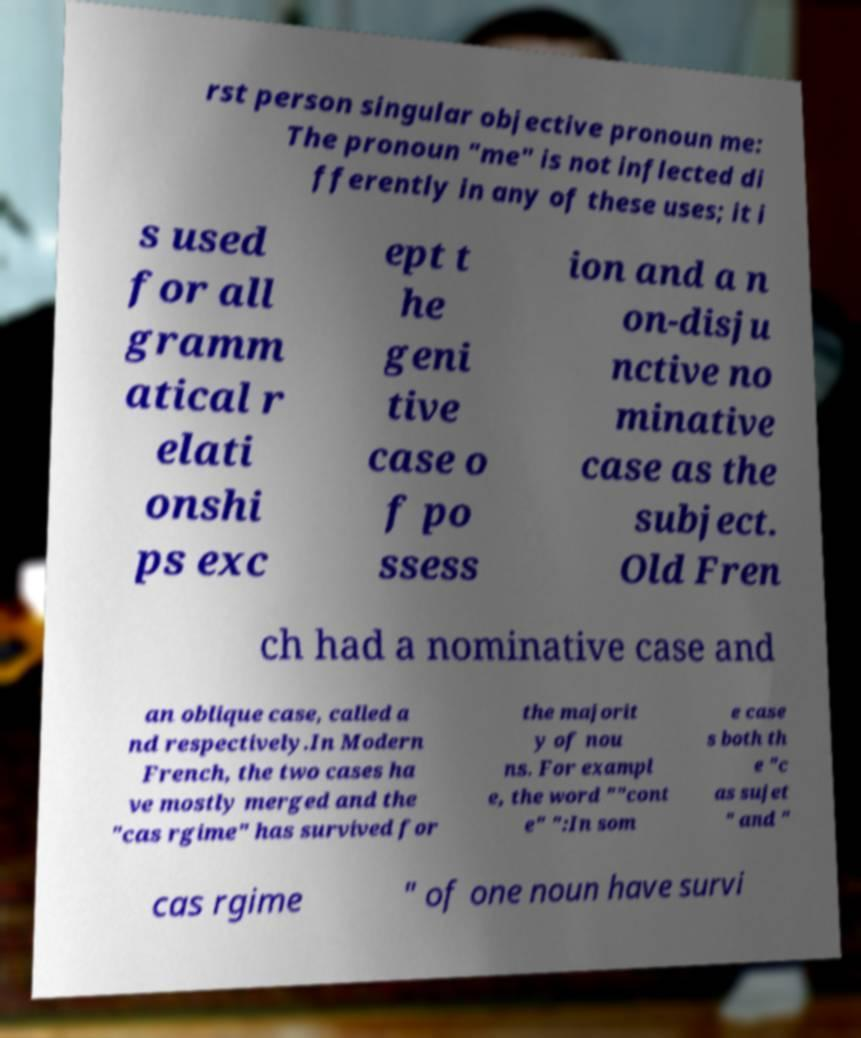What messages or text are displayed in this image? I need them in a readable, typed format. rst person singular objective pronoun me: The pronoun "me" is not inflected di fferently in any of these uses; it i s used for all gramm atical r elati onshi ps exc ept t he geni tive case o f po ssess ion and a n on-disju nctive no minative case as the subject. Old Fren ch had a nominative case and an oblique case, called a nd respectively.In Modern French, the two cases ha ve mostly merged and the "cas rgime" has survived for the majorit y of nou ns. For exampl e, the word ""cont e" ":In som e case s both th e "c as sujet " and " cas rgime " of one noun have survi 